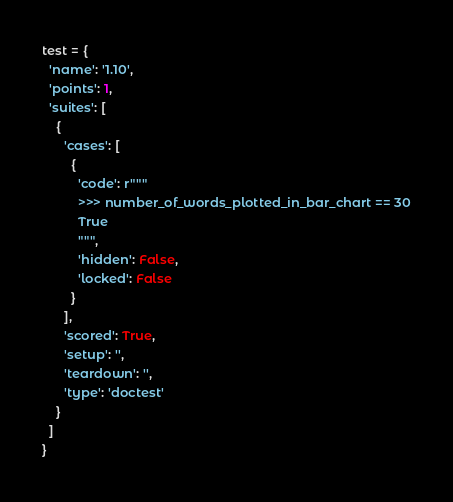Convert code to text. <code><loc_0><loc_0><loc_500><loc_500><_Python_>test = {
  'name': '1.10',
  'points': 1,
  'suites': [
    {
      'cases': [
        {
          'code': r"""
          >>> number_of_words_plotted_in_bar_chart == 30
          True
          """,
          'hidden': False,
          'locked': False
        }
      ],
      'scored': True,
      'setup': '',
      'teardown': '',
      'type': 'doctest'
    }
  ]
}
</code> 